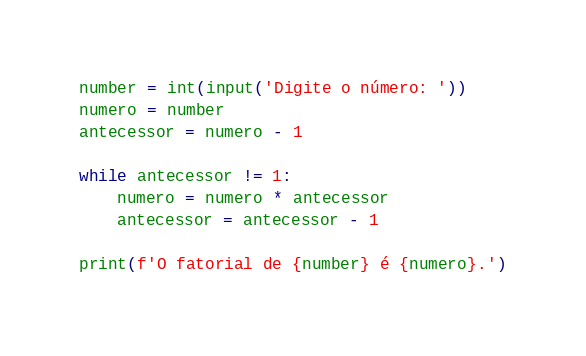Convert code to text. <code><loc_0><loc_0><loc_500><loc_500><_Python_>number = int(input('Digite o número: '))
numero = number
antecessor = numero - 1

while antecessor != 1:
    numero = numero * antecessor
    antecessor = antecessor - 1

print(f'O fatorial de {number} é {numero}.')
</code> 